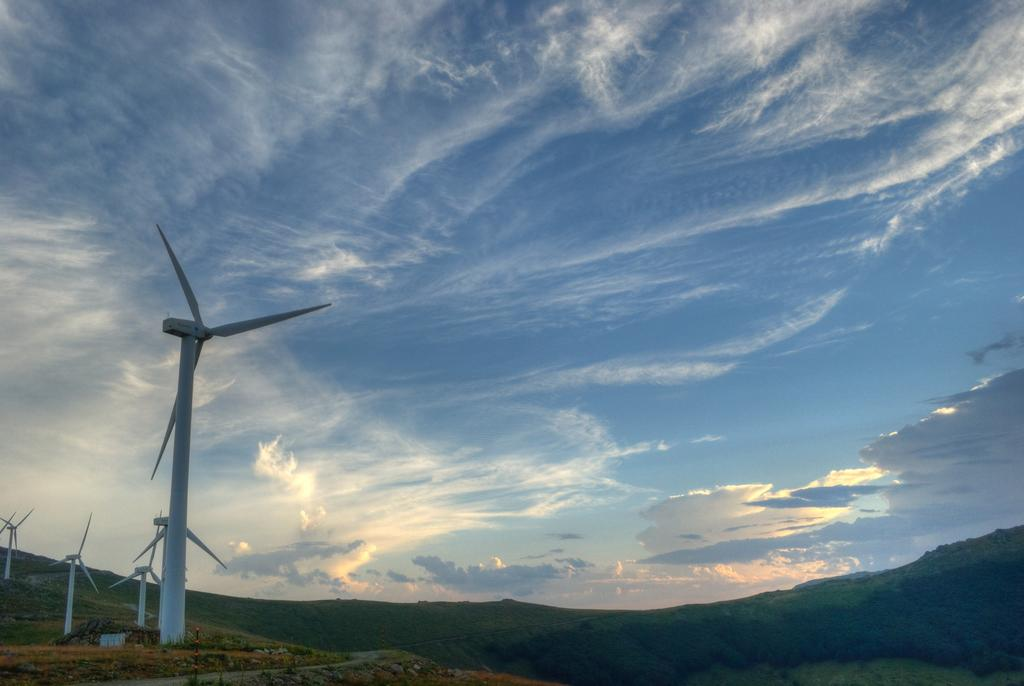What structures can be seen on the left side of the image? There are wind turbines on the left side of the image. What is visible at the top of the image? The sky is visible at the top of the image. What can be seen in the background of the image? There are hills in the background of the image, with trees and grass visible on them. Where is the bike located in the image? There is no bike present in the image. Can you see any bananas growing on the trees in the image? There is no mention of bananas in the image; the trees are not specified as fruit-bearing trees. 